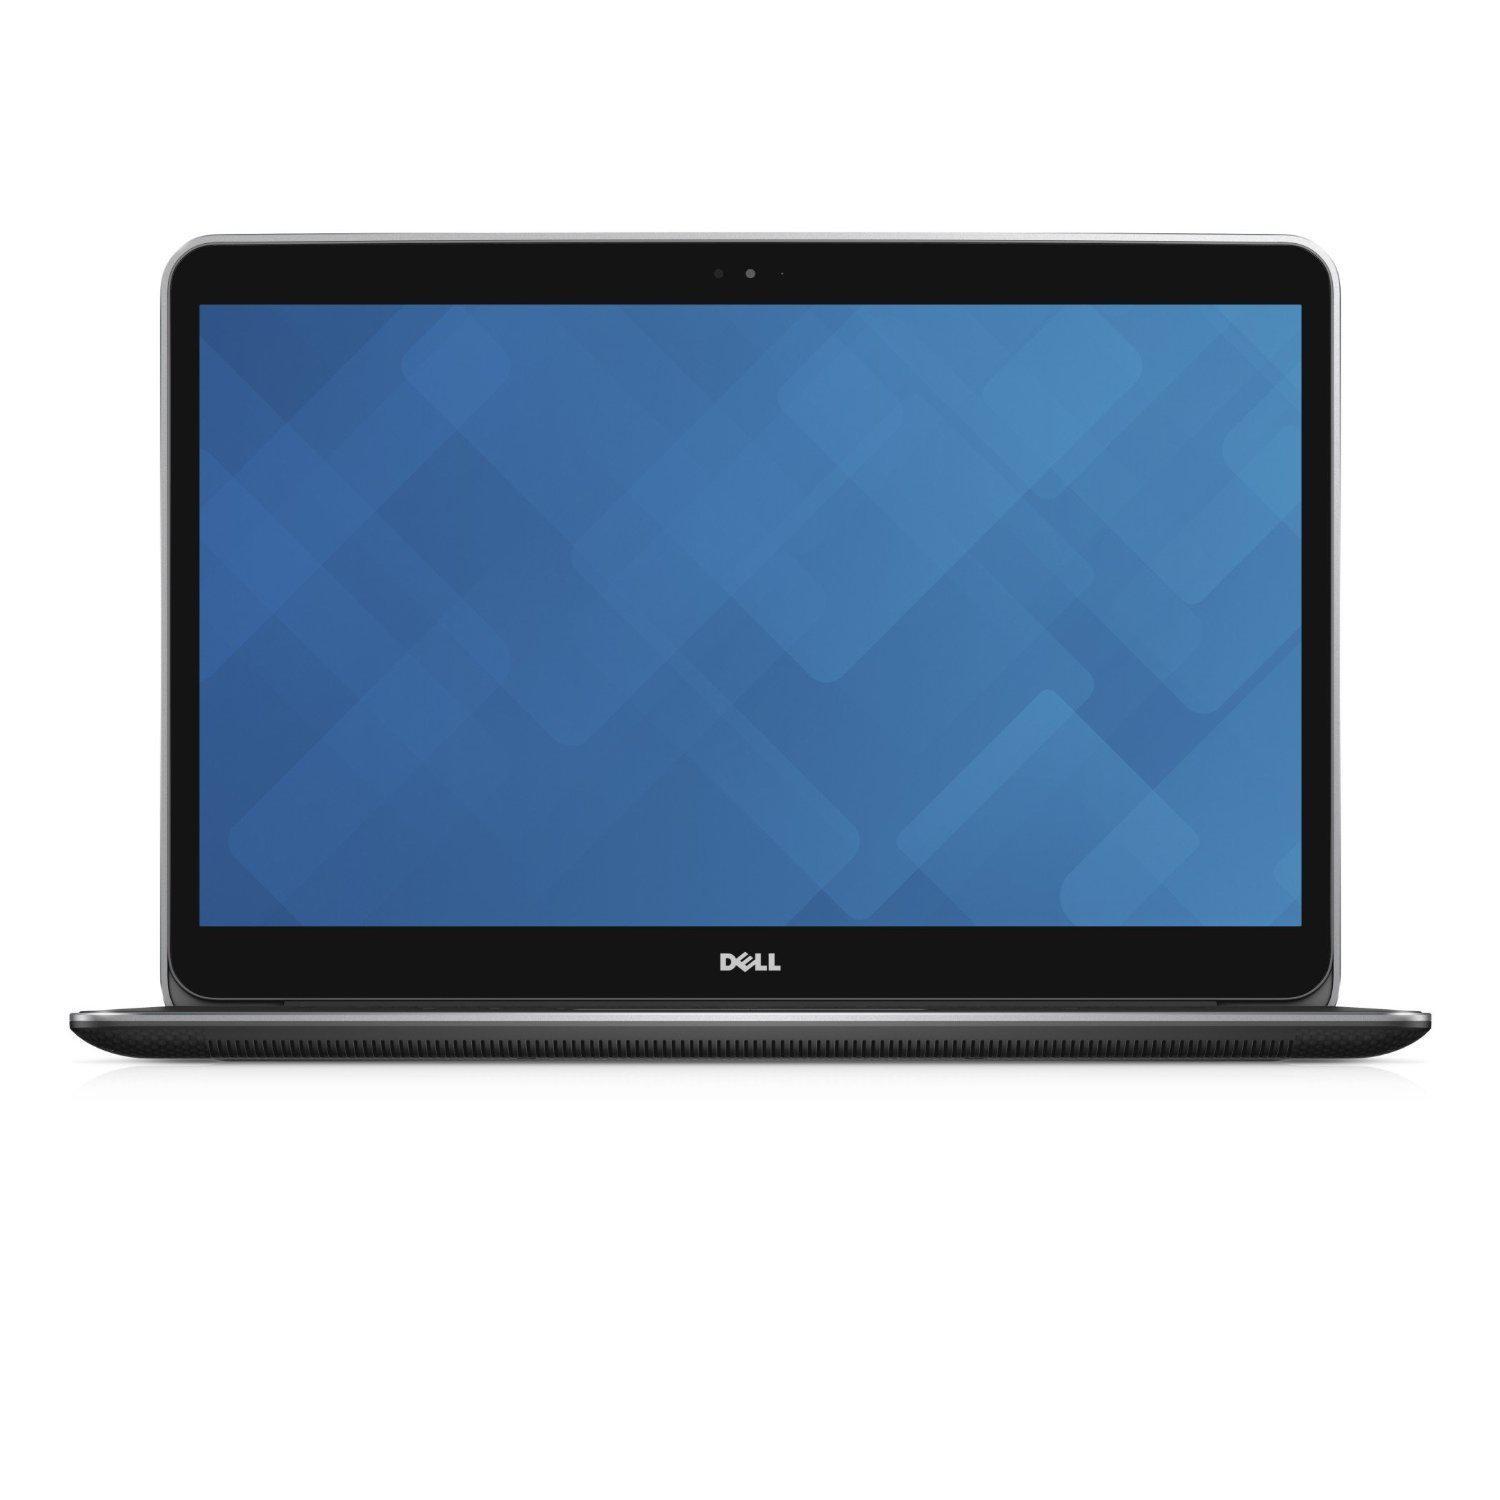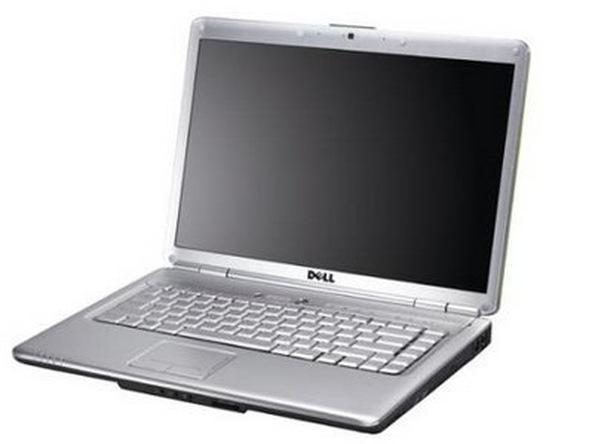The first image is the image on the left, the second image is the image on the right. Given the left and right images, does the statement "One of the laptops has wallpaper that looks like light shining through a window." hold true? Answer yes or no. No. The first image is the image on the left, the second image is the image on the right. Considering the images on both sides, is "One of the images shows an open laptop viewed head-on, with a screen displaying a blue background." valid? Answer yes or no. Yes. 